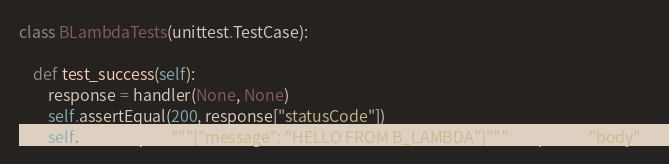Convert code to text. <code><loc_0><loc_0><loc_500><loc_500><_Python_>
class BLambdaTests(unittest.TestCase):

    def test_success(self):
        response = handler(None, None)
        self.assertEqual(200, response["statusCode"])
        self.assertEqual("""{"message": "HELLO FROM B_LAMBDA"}""", response["body"])
</code> 